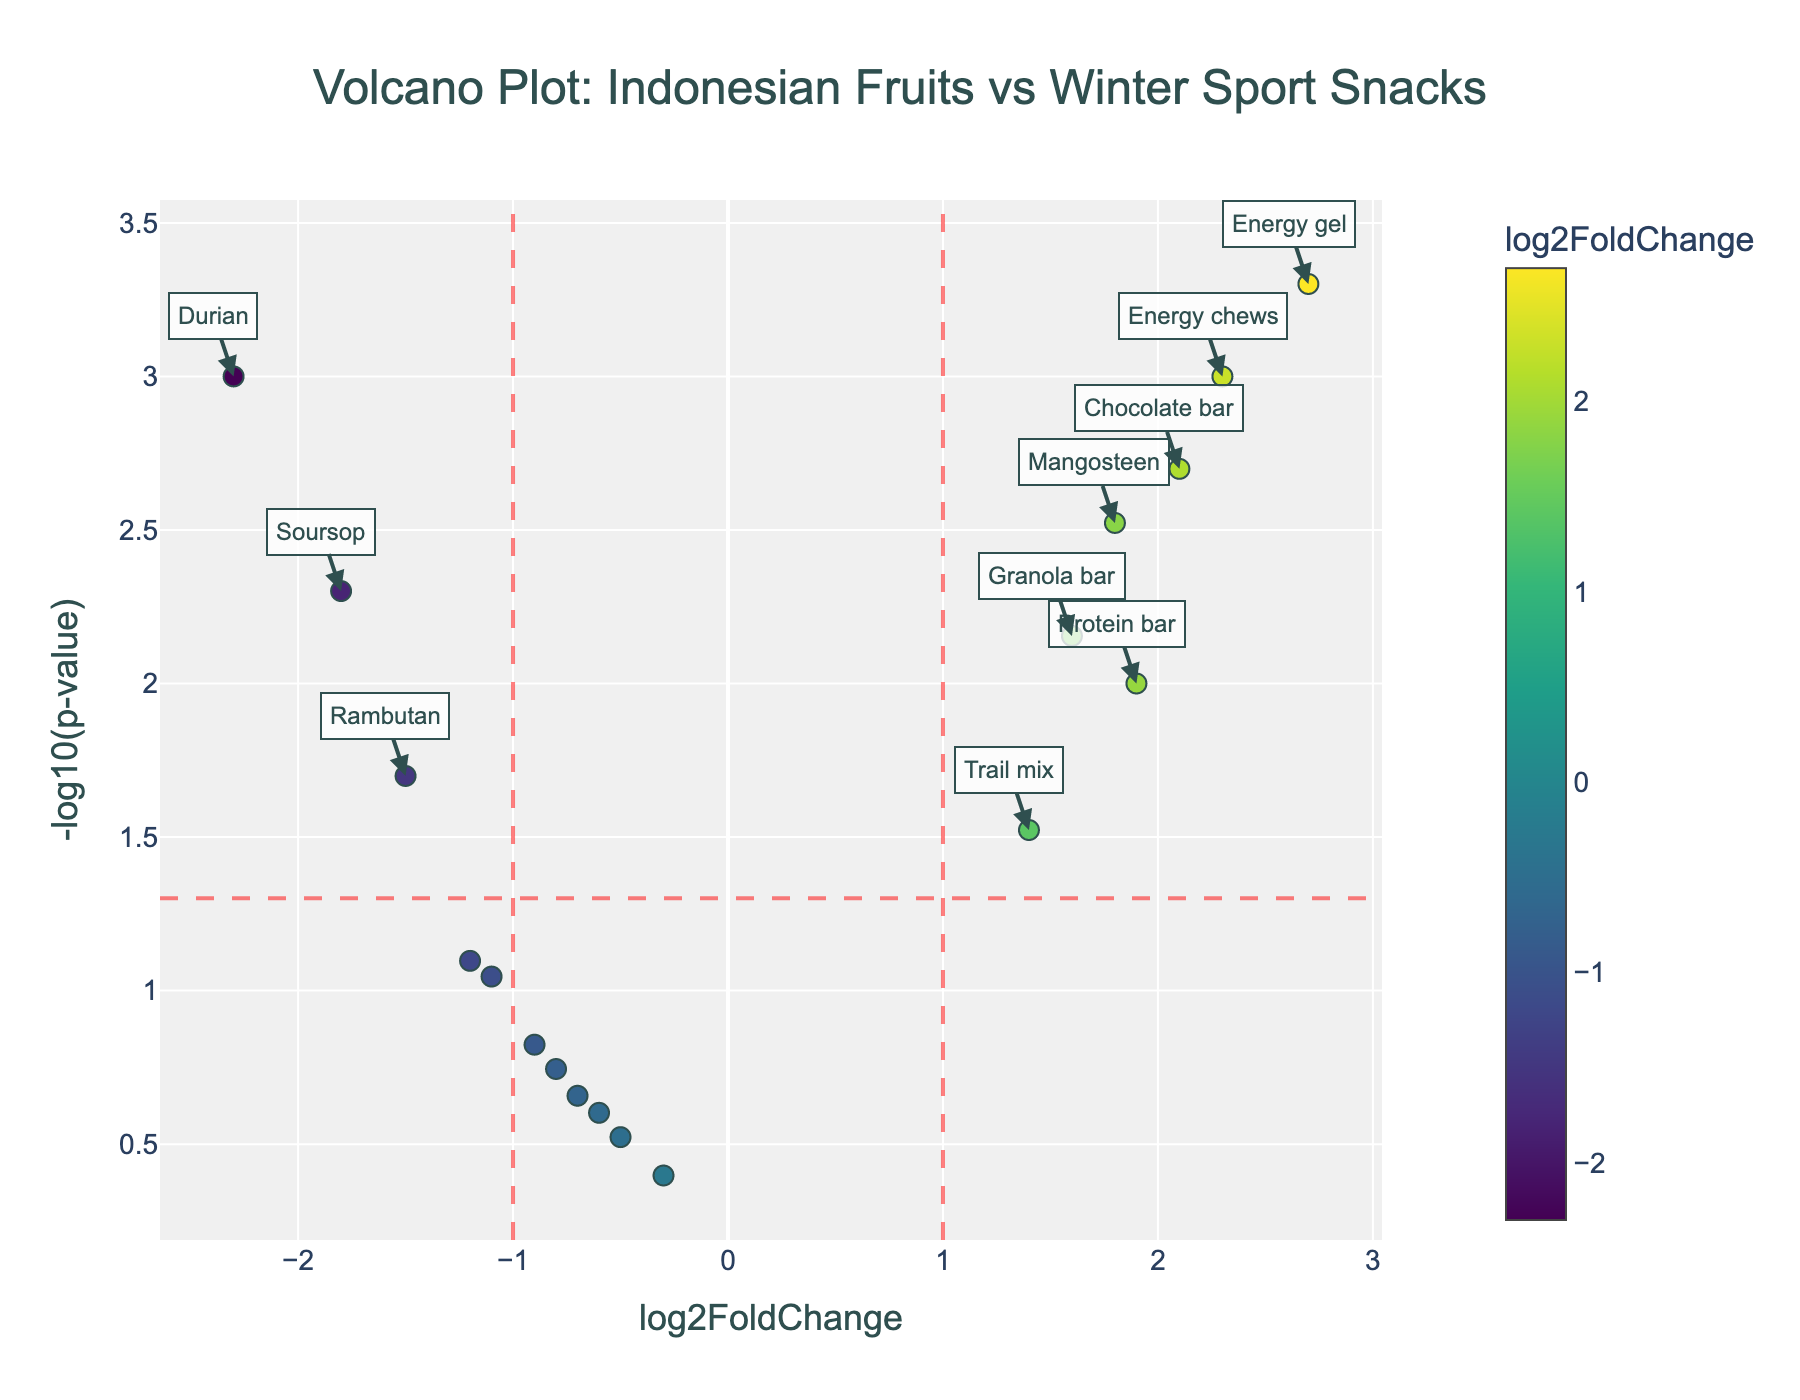What is the title of the figure? The title is usually located at the top of the figure. For this plot, it reads "Volcano Plot: Indonesian Fruits vs Winter Sport Snacks."
Answer: Volcano Plot: Indonesian Fruits vs Winter Sport Snacks How many data points are represented in the figure? Count the number of markers (data points) displayed in the plot. There are markers for each compound listed in the data.
Answer: 18 Which compound has the highest log2FoldChange? Look at the x-axis (log2FoldChange) to find the marker farthest to the right. The compound with the highest log2FoldChange is "Energy gel."
Answer: Energy gel How many compounds have a log2FoldChange greater than 1 and a p-value less than 0.05? Identify the markers in the top-right quadrant of the plot, which meet both criteria of being above the x=1 line and to the right of the y=-log10(0.05) horizontal line. The compounds are: Chocolate bar, Energy gel, Energy chews, and Protein bar.
Answer: 4 Which compound has the smallest p-value? Look at the y-axis (-log10(p-value)) to find the marker farthest up. The compound with the smallest p-value is "Energy gel."
Answer: Energy gel Compare the log2FoldChange of Durian and Chocolate bar. Which one is higher, and by how much? Find the log2FoldChange values for both compounds. Durian has -2.3, and Chocolate bar has 2.1. Subtract the values to find the difference: 2.1 - (-2.3) = 4.4.
Answer: Chocolate bar by 4.4 What is the -log10(p-value) for Mangosteen? Convert the p-value of Mangosteen (0.003) to -log10(p-value). The calculation is -log10(0.003) ≈ 2.52.
Answer: 2.52 Which compound falls closest to having no difference in log2FoldChange (i.e., closest to 0)? Look at the x-axis (log2FoldChange) and find the marker closest to 0. "Coconut water" has a log2FoldChange of -0.3, which is the closest to 0.
Answer: Coconut water How many compounds are significantly down-regulated (log2FoldChange < -1 and p-value < 0.05)? Identify markers that are below the x=-1 vertical line and above the y=-log10(0.05) horizontal line. The compounds are Durian, Rambutan, and Soursop.
Answer: 3 